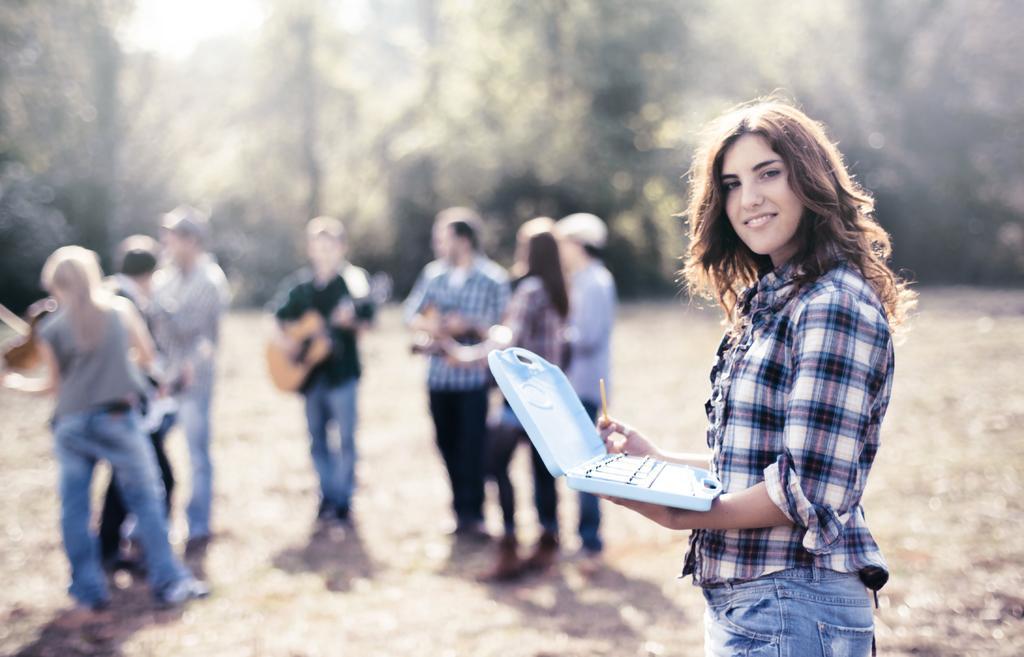Can you describe this image briefly? In the image we can see a woman standing, wearing clothes and she is smiling, and she is holding an object in her hands. We can see there are even other people standing, wearing clothes and the background is blurred. 